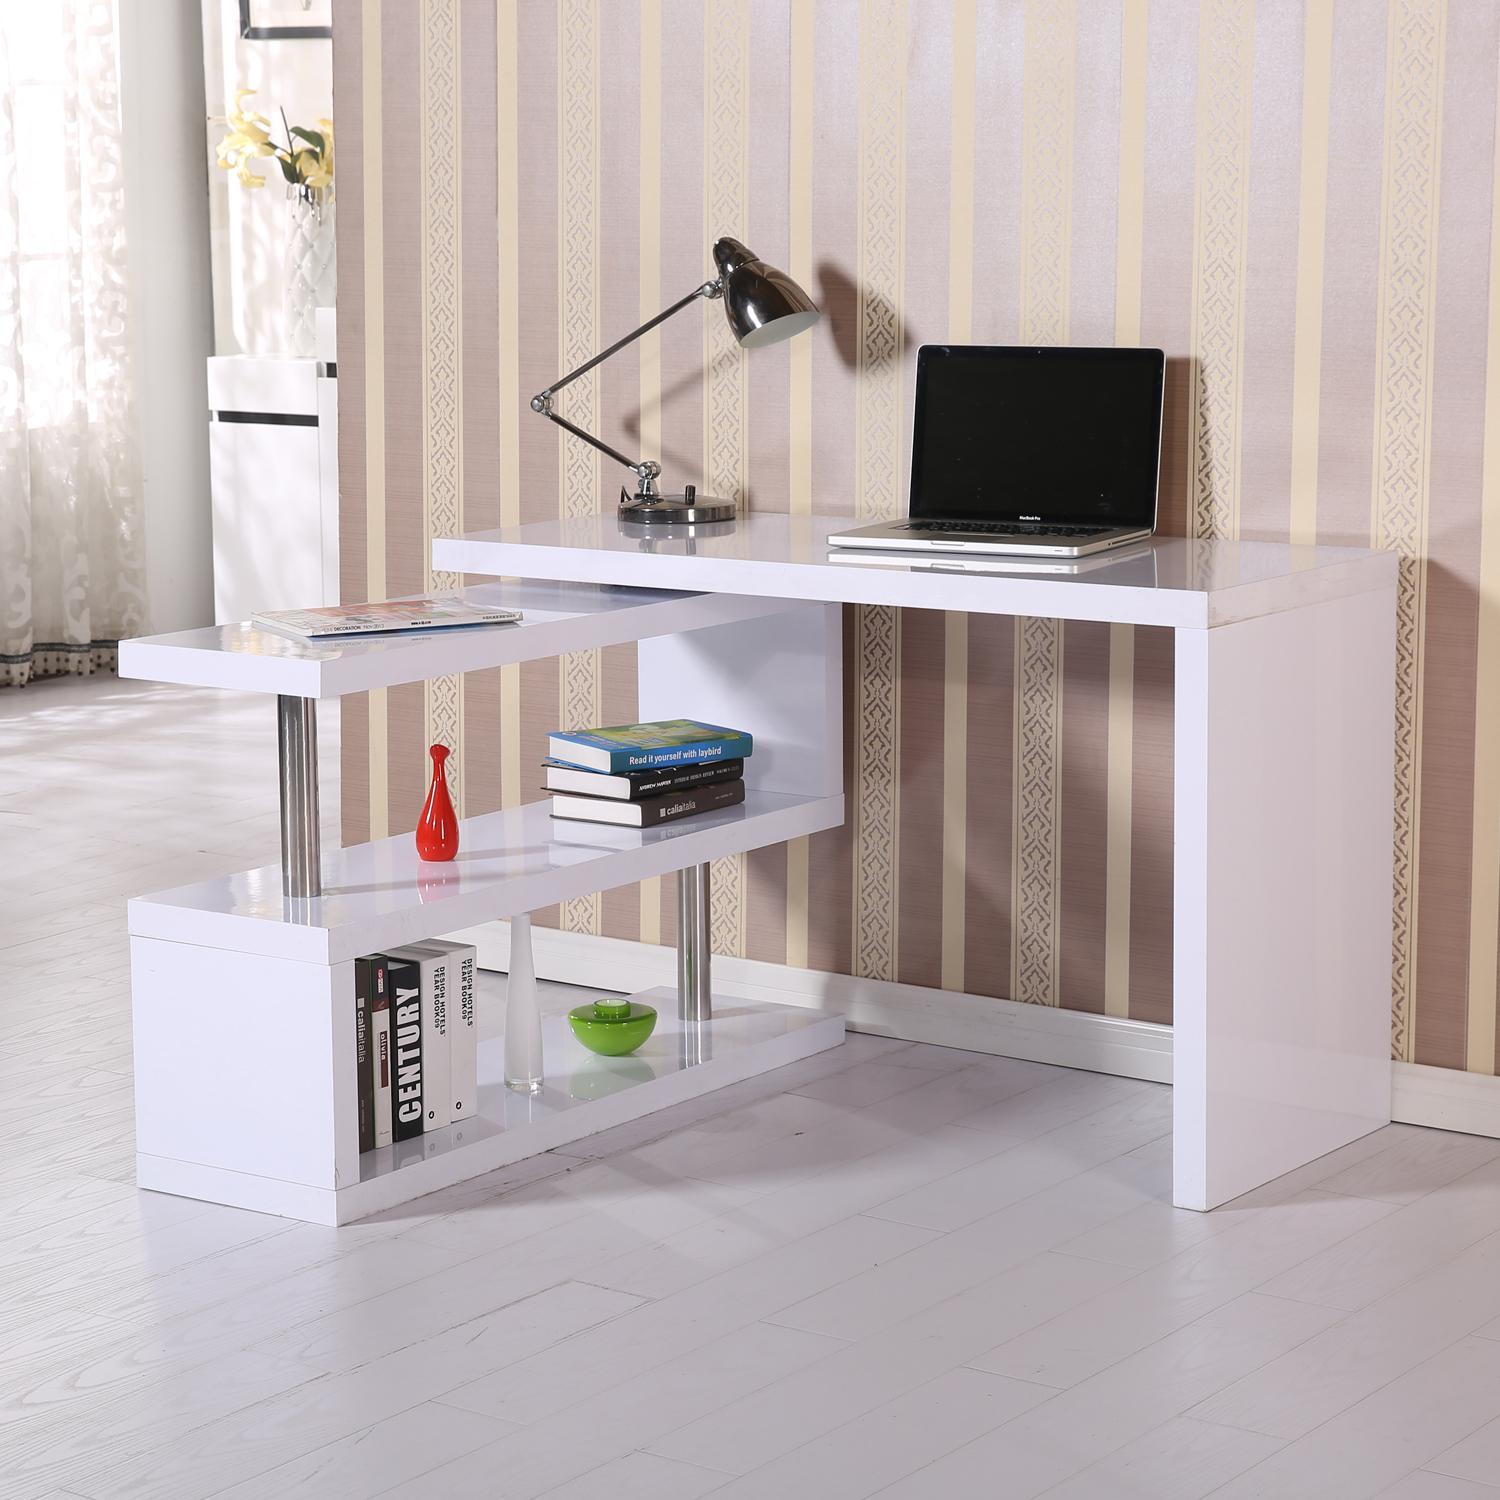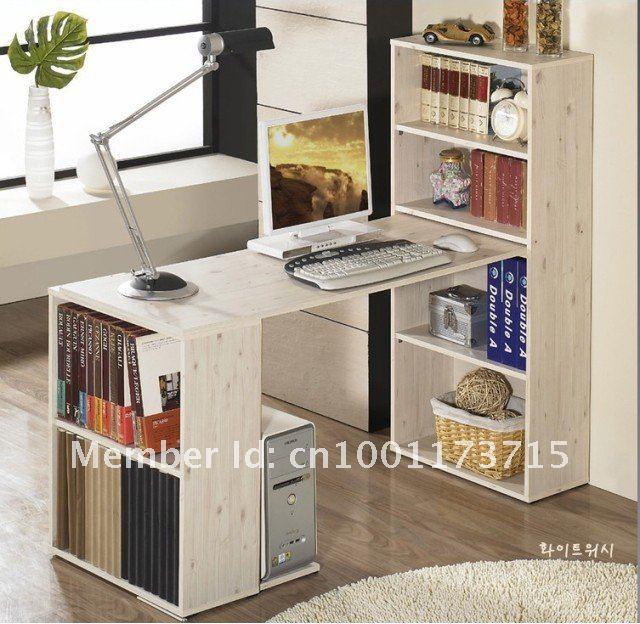The first image is the image on the left, the second image is the image on the right. Evaluate the accuracy of this statement regarding the images: "There is a chair pulled up to at least one of the desks.". Is it true? Answer yes or no. No. The first image is the image on the left, the second image is the image on the right. Given the left and right images, does the statement "There is a chair on wheels next to a desk." hold true? Answer yes or no. No. 